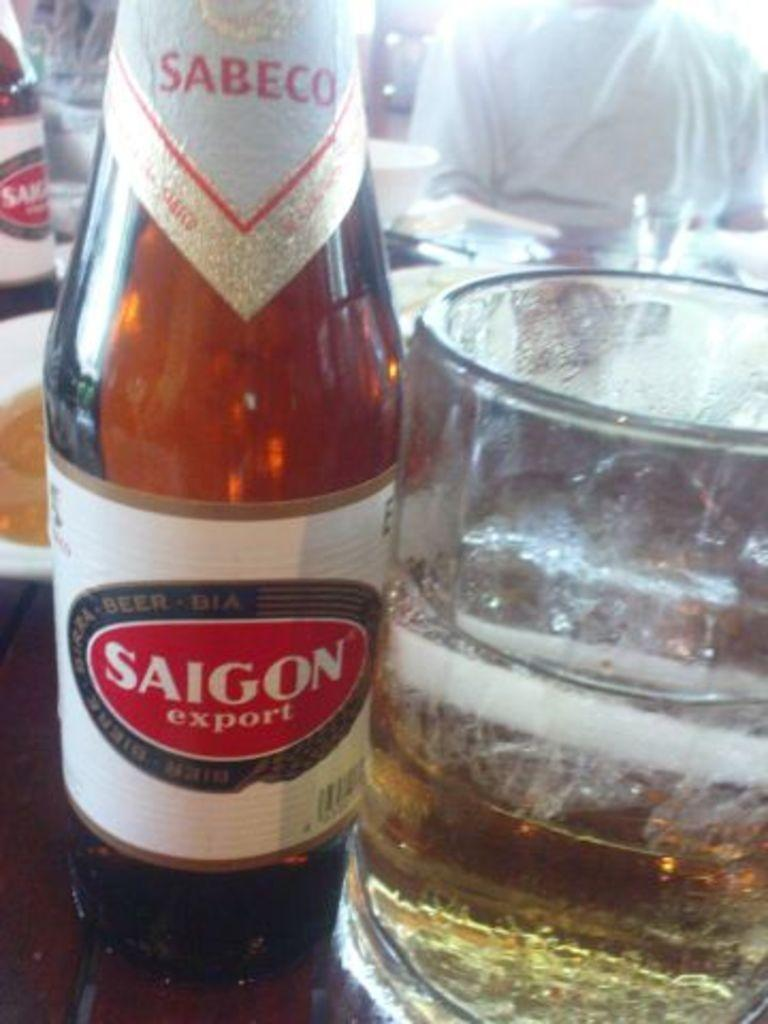<image>
Present a compact description of the photo's key features. A bottle of Sabeco Saigon export is on a table next to a glass. 